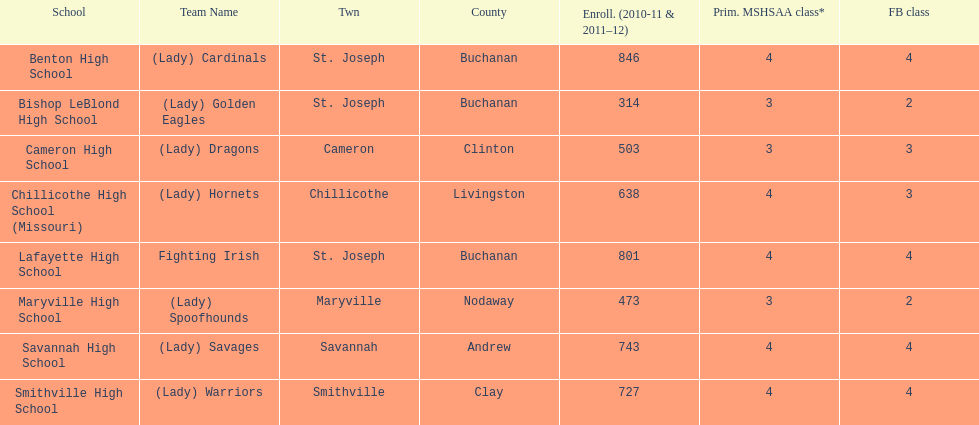Does lafayette high school or benton high school have green and grey as their colors? Lafayette High School. 